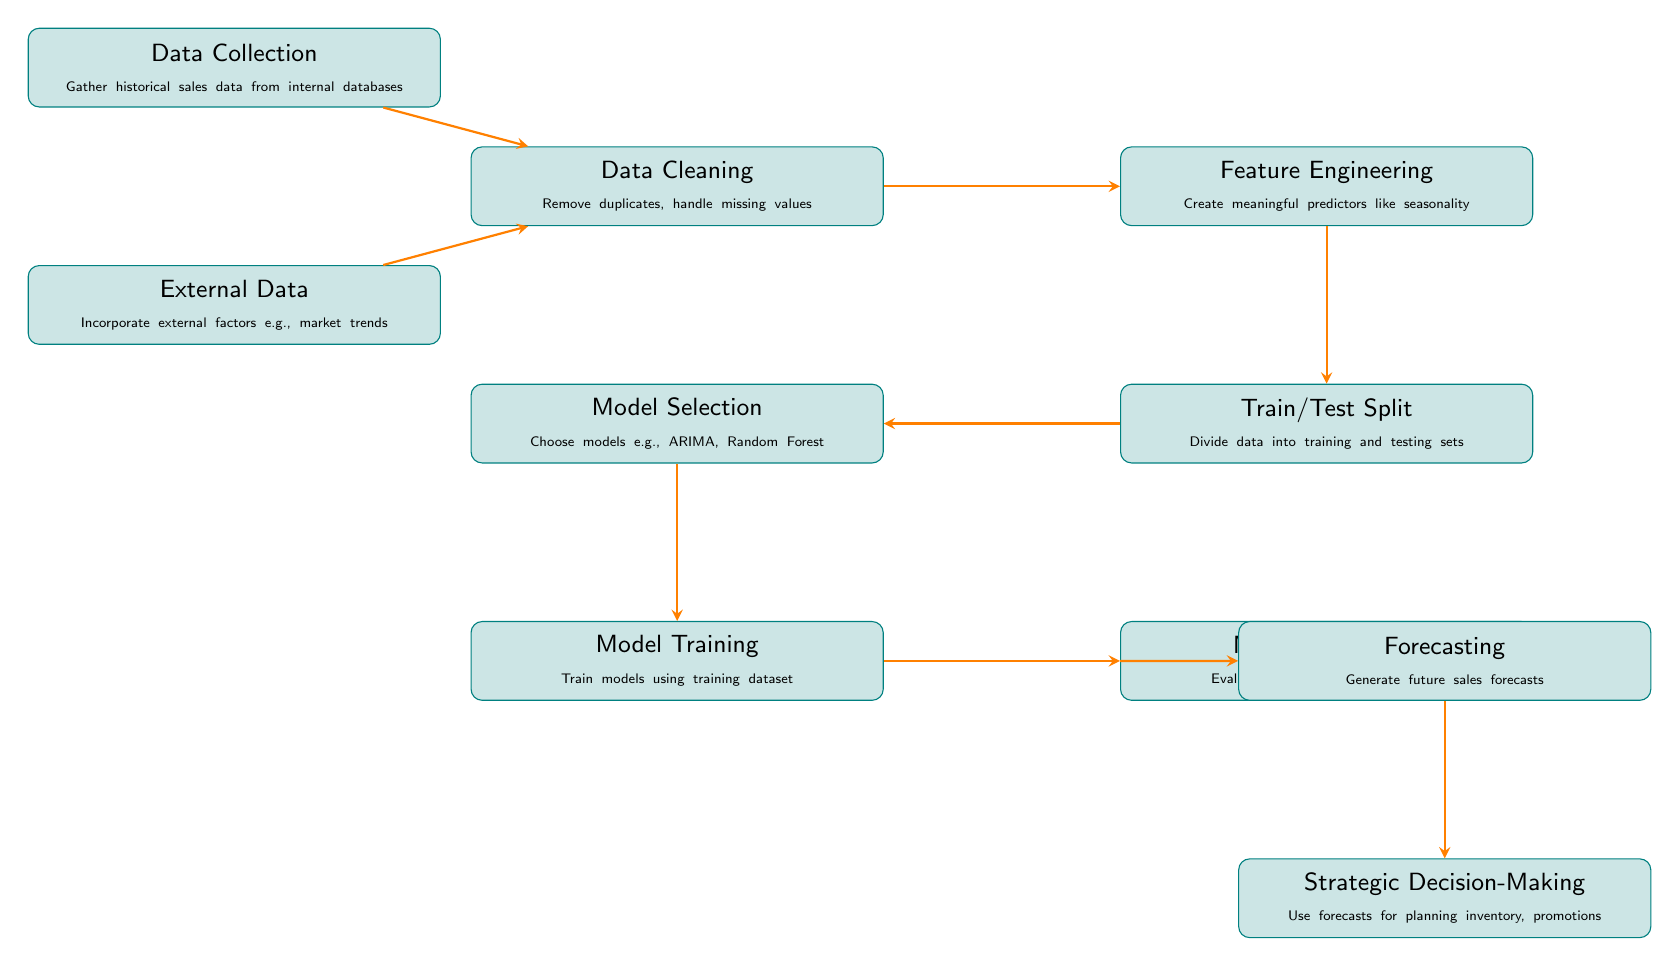What is the first step in the sales forecast model process? The diagram indicates that the first step is "Data Collection," which involves gathering historical sales data from internal databases.
Answer: Data Collection How many total nodes are in the diagram? Counting each of the individual processes in the diagram results in a total of 9 nodes.
Answer: 9 Which two processes are connected by the edge labeled "leads to"? The processes "Train/Test Split" and "Model Selection" are connected by the edge that indicates "leads to."
Answer: Train/Test Split and Model Selection What is the purpose of "Feature Engineering" in the process? "Feature Engineering" is responsible for creating meaningful predictors like seasonality that can improve model performance.
Answer: Create meaningful predictors Which model evaluation metric is mentioned in the diagram? The diagram lists RMSE and MAE as metrics used for evaluating models.
Answer: RMSE, MAE What does the "Forecasting" process inform? The "Forecasting" process directly informs "Strategic Decision-Making" regarding planning inventory and promotions.
Answer: Strategic Decision-Making What is the relationship between "Data Cleaning" and "Feature Engineering"? The relationship is that "Data Cleaning" feeds into "Feature Engineering," meaning cleaned data serves as input for feature creation.
Answer: Feeds into What follows model evaluation in the sales forecast model? The process that follows "Model Evaluation" is "Forecasting," where future sales forecasts are generated.
Answer: Forecasting What type of data is incorporated into the model from external sources? The external data incorporates factors such as market trends, which can influence sales forecasts.
Answer: Market trends 